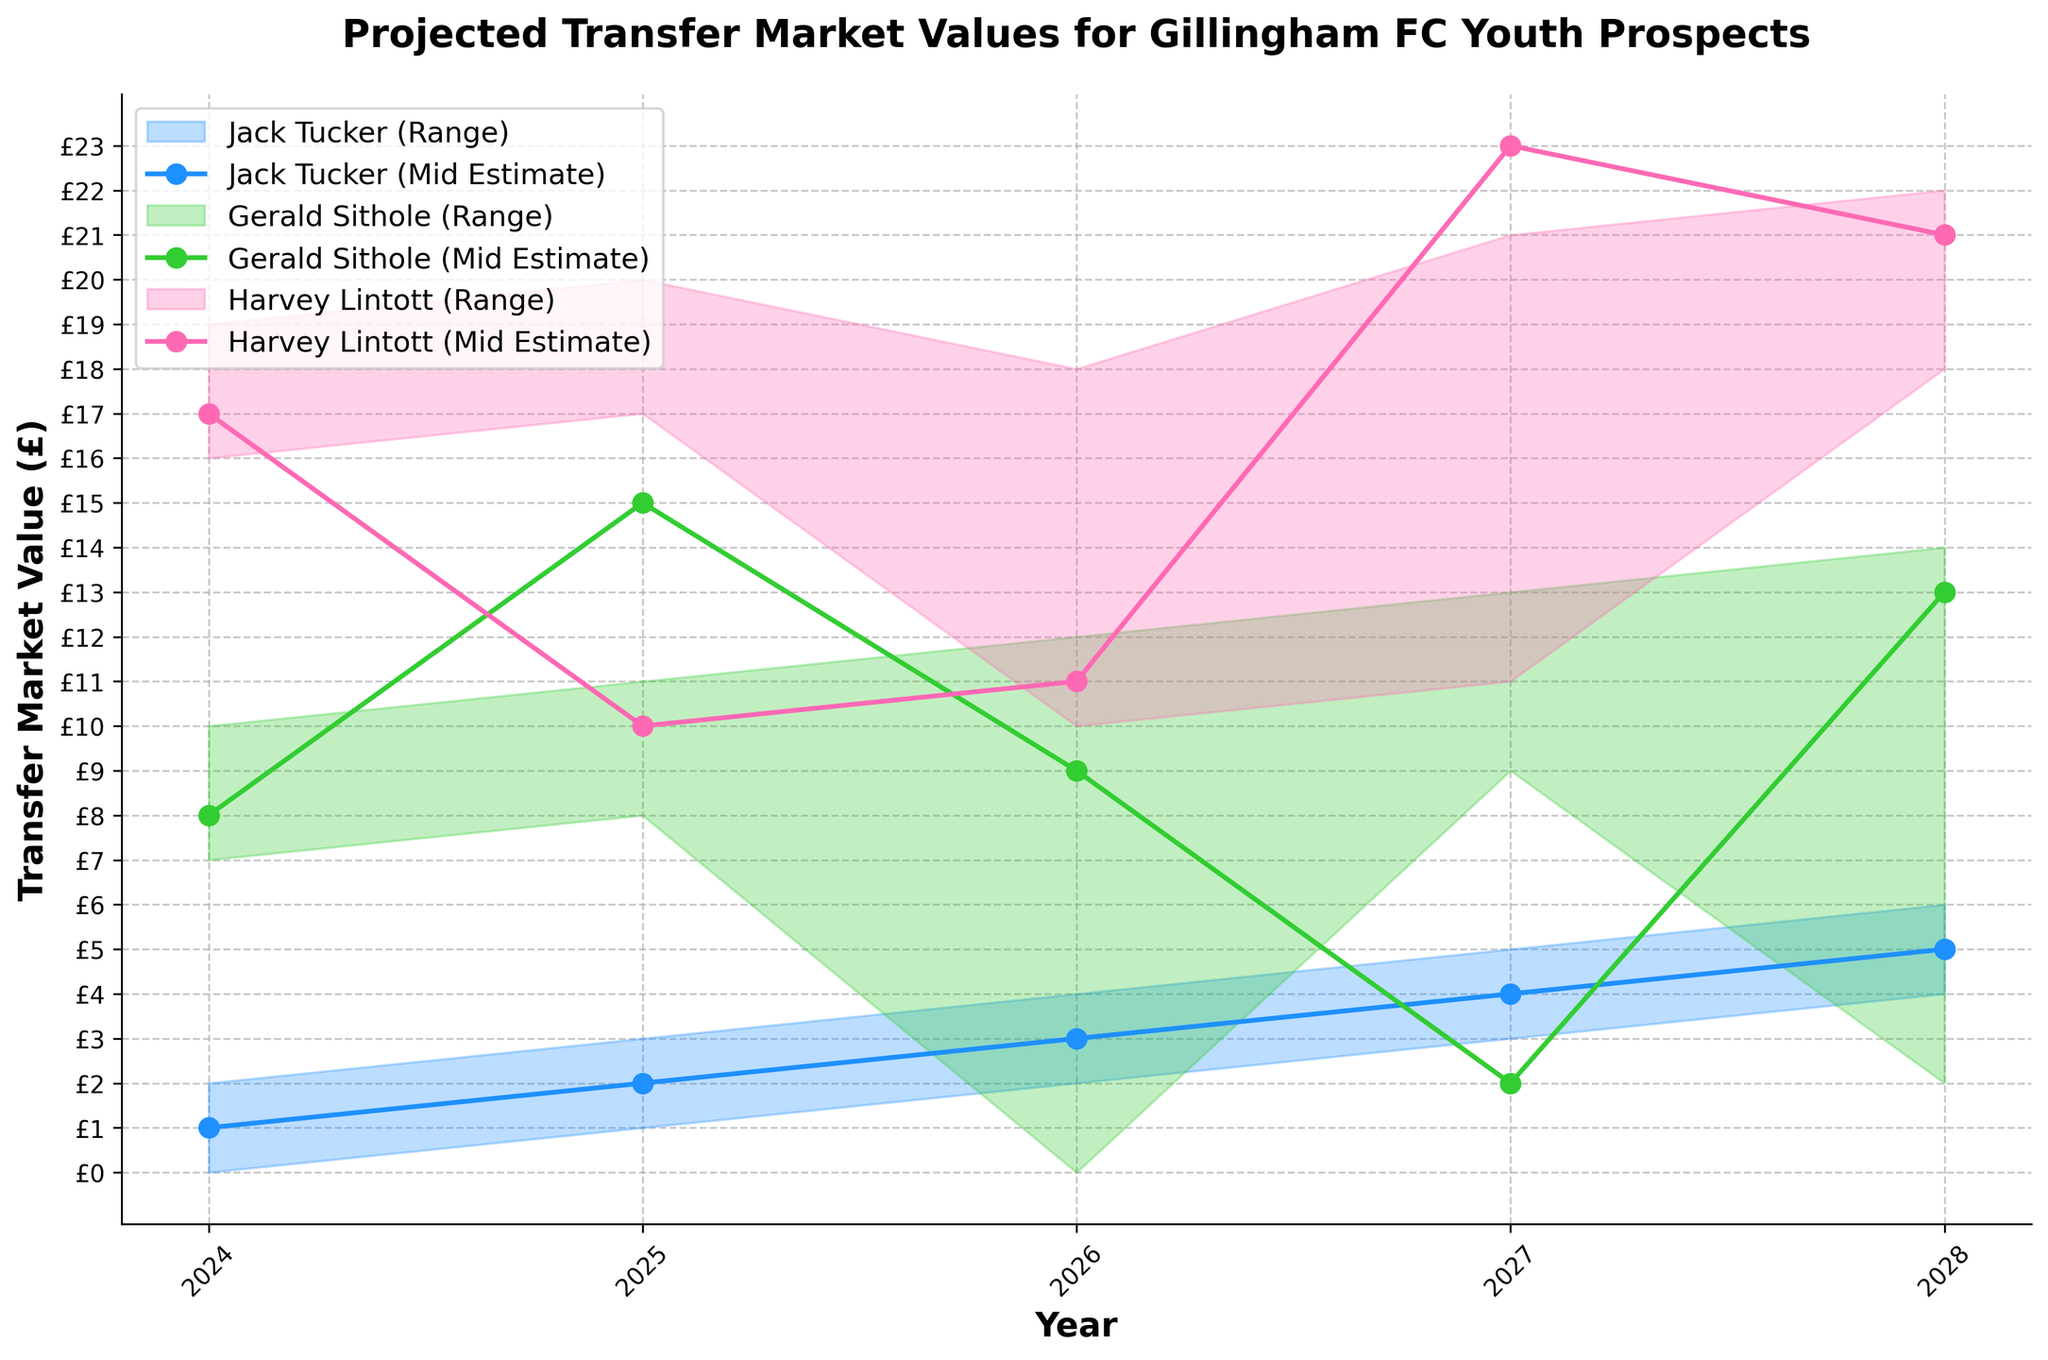What is the title of the figure? The title is usually found at the top of the figure and is prominently displayed.
Answer: Projected Transfer Market Values for Gillingham FC Youth Prospects How many players' projections are shown in the figure? The figure should show distinct colors and labels for each player's projections. By counting these, we can determine the number of players.
Answer: 3 Which player's transfer value is projected to be the highest in 2028? By looking at the 2028 data points and comparing the High Estimate values for all players, we can see that Jack Tucker has the highest projection.
Answer: Jack Tucker What is the mid estimate of Gerald Sithole in 2025? Locate Gerald Sithole's data for the year 2025 and identify the mid estimate value.
Answer: £450000 What's the range of Jack Tucker's projected transfer value in 2026? The range can be found by subtracting the Low Estimate from the High Estimate for the specific year and player. For 2026, it's £2000000 - £1000000.
Answer: £1000000 Which player has the smallest increase in Mid Estimate from 2024 to 2025? To answer this, we find the difference in Mid Estimate for each player between 2024 and 2025 and then compare these differences. Gerald Sithole: (£450000 - £300000) = £150000, Harvey Lintott: (£400000 - £250000) = £150000, Jack Tucker: (£1000000 - £750000) = £250000.
Answer: Gerald Sithole and Harvey Lintott What is the projected Mid Estimate difference between the highest and lowest valued player in 2027? Identify the highest and lowest Mid Estimate values for the year 2027 and calculate the difference. Jack Tucker: £2000000, Gerald Sithole: £1000000, Harvey Lintott: £850000. The difference is £2000000 - £850000.
Answer: £1150000 By how much is Harvey Lintott's High Estimate projected to increase from 2025 to 2028? Calculate the High Estimate for 2028 ( £1400000) and subtract the High Estimate for 2025 (£550000) to find the increase.
Answer: £850000 